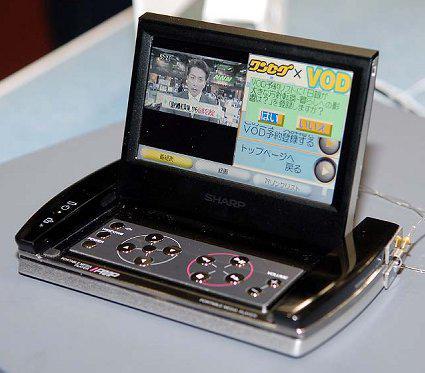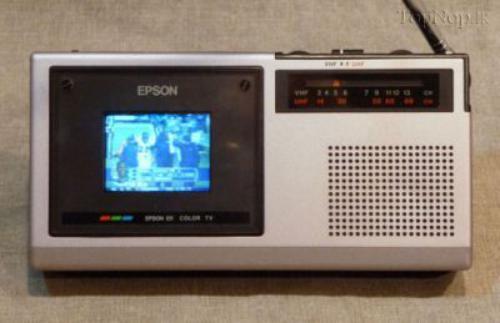The first image is the image on the left, the second image is the image on the right. Given the left and right images, does the statement "The right image shows one pale-colored device with an antenna angled leftward and a grid of dots on its front." hold true? Answer yes or no. Yes. The first image is the image on the left, the second image is the image on the right. For the images displayed, is the sentence "The right image contains  television with an antenna." factually correct? Answer yes or no. Yes. 